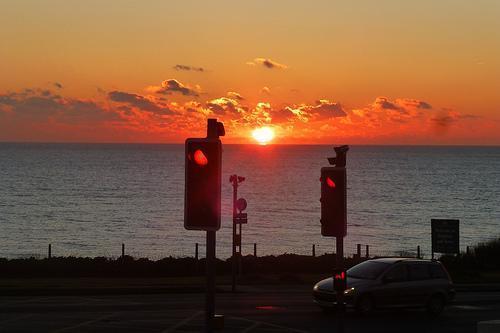How many traffic lights on the road?
Give a very brief answer. 2. 